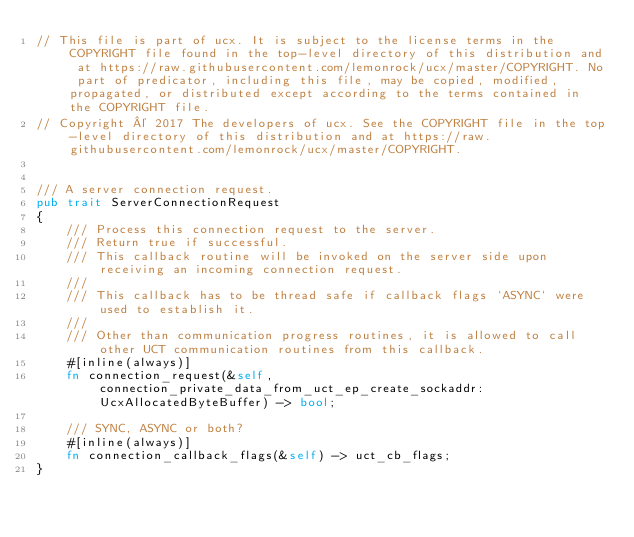Convert code to text. <code><loc_0><loc_0><loc_500><loc_500><_Rust_>// This file is part of ucx. It is subject to the license terms in the COPYRIGHT file found in the top-level directory of this distribution and at https://raw.githubusercontent.com/lemonrock/ucx/master/COPYRIGHT. No part of predicator, including this file, may be copied, modified, propagated, or distributed except according to the terms contained in the COPYRIGHT file.
// Copyright © 2017 The developers of ucx. See the COPYRIGHT file in the top-level directory of this distribution and at https://raw.githubusercontent.com/lemonrock/ucx/master/COPYRIGHT.


/// A server connection request.
pub trait ServerConnectionRequest
{
	/// Process this connection request to the server.
	/// Return true if successful.
	/// This callback routine will be invoked on the server side upon receiving an incoming connection request.
	///
	/// This callback has to be thread safe if callback flags `ASYNC` were used to establish it.
	///
	/// Other than communication progress routines, it is allowed to call other UCT communication routines from this callback.
	#[inline(always)]
	fn connection_request(&self, connection_private_data_from_uct_ep_create_sockaddr: UcxAllocatedByteBuffer) -> bool;
	
	/// SYNC, ASYNC or both?
	#[inline(always)]
	fn connection_callback_flags(&self) -> uct_cb_flags;
}
</code> 